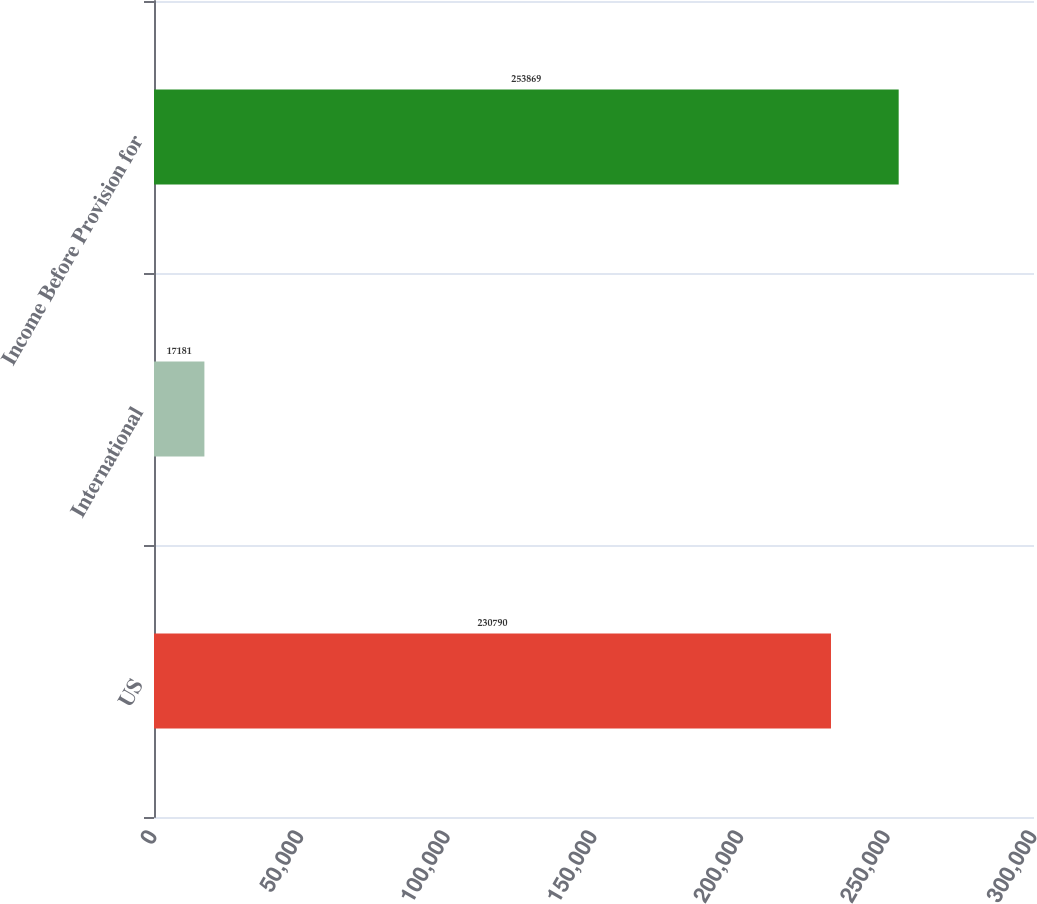Convert chart. <chart><loc_0><loc_0><loc_500><loc_500><bar_chart><fcel>US<fcel>International<fcel>Income Before Provision for<nl><fcel>230790<fcel>17181<fcel>253869<nl></chart> 